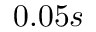<formula> <loc_0><loc_0><loc_500><loc_500>0 . 0 5 s</formula> 